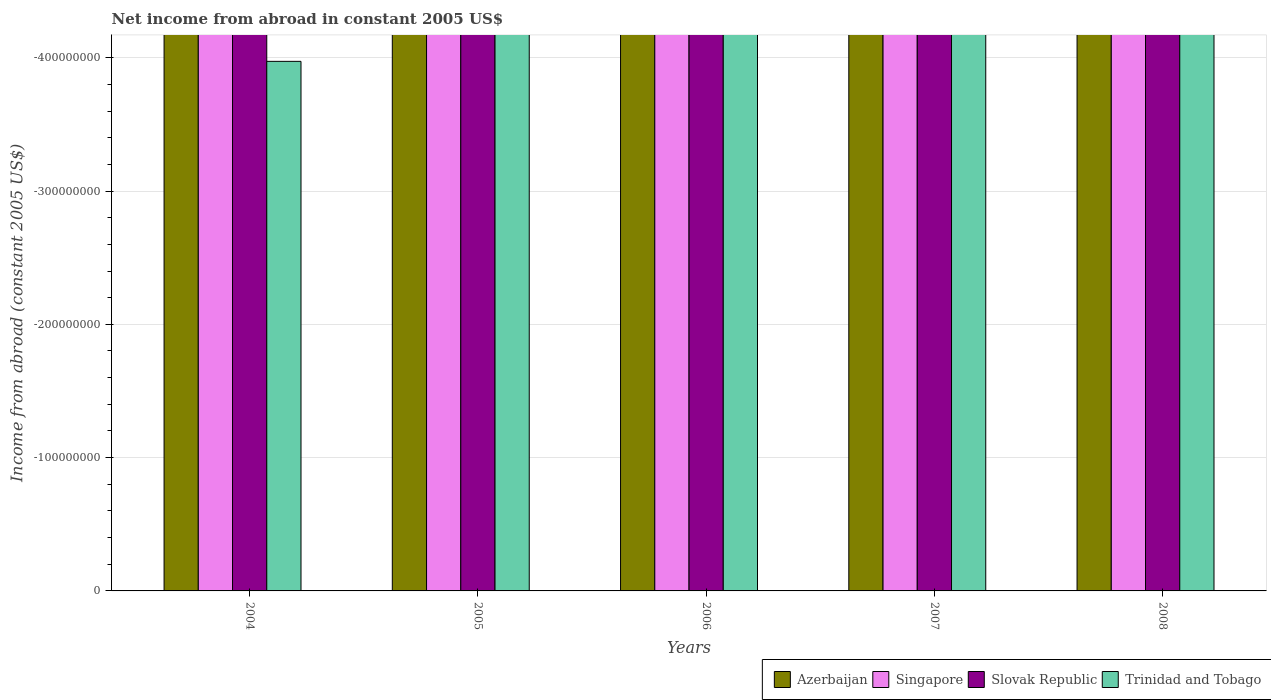Are the number of bars per tick equal to the number of legend labels?
Your response must be concise. No. In how many cases, is the number of bars for a given year not equal to the number of legend labels?
Your answer should be compact. 5. What is the net income from abroad in Slovak Republic in 2006?
Offer a very short reply. 0. What is the difference between the net income from abroad in Azerbaijan in 2007 and the net income from abroad in Trinidad and Tobago in 2005?
Offer a terse response. 0. What is the average net income from abroad in Slovak Republic per year?
Offer a terse response. 0. In how many years, is the net income from abroad in Singapore greater than the average net income from abroad in Singapore taken over all years?
Your answer should be very brief. 0. Is it the case that in every year, the sum of the net income from abroad in Trinidad and Tobago and net income from abroad in Slovak Republic is greater than the net income from abroad in Singapore?
Offer a terse response. No. How many bars are there?
Offer a terse response. 0. Where does the legend appear in the graph?
Your response must be concise. Bottom right. What is the title of the graph?
Offer a very short reply. Net income from abroad in constant 2005 US$. Does "Norway" appear as one of the legend labels in the graph?
Keep it short and to the point. No. What is the label or title of the X-axis?
Offer a very short reply. Years. What is the label or title of the Y-axis?
Give a very brief answer. Income from abroad (constant 2005 US$). What is the Income from abroad (constant 2005 US$) in Singapore in 2004?
Your answer should be compact. 0. What is the Income from abroad (constant 2005 US$) of Trinidad and Tobago in 2004?
Provide a short and direct response. 0. What is the Income from abroad (constant 2005 US$) in Azerbaijan in 2005?
Your response must be concise. 0. What is the Income from abroad (constant 2005 US$) of Singapore in 2005?
Keep it short and to the point. 0. What is the Income from abroad (constant 2005 US$) of Trinidad and Tobago in 2005?
Provide a succinct answer. 0. What is the Income from abroad (constant 2005 US$) of Azerbaijan in 2006?
Provide a short and direct response. 0. What is the Income from abroad (constant 2005 US$) in Slovak Republic in 2006?
Your answer should be compact. 0. What is the Income from abroad (constant 2005 US$) of Azerbaijan in 2007?
Offer a very short reply. 0. What is the Income from abroad (constant 2005 US$) in Slovak Republic in 2007?
Make the answer very short. 0. What is the Income from abroad (constant 2005 US$) in Slovak Republic in 2008?
Your answer should be compact. 0. What is the Income from abroad (constant 2005 US$) in Trinidad and Tobago in 2008?
Offer a terse response. 0. What is the total Income from abroad (constant 2005 US$) in Slovak Republic in the graph?
Your response must be concise. 0. What is the average Income from abroad (constant 2005 US$) of Azerbaijan per year?
Make the answer very short. 0. What is the average Income from abroad (constant 2005 US$) of Singapore per year?
Offer a very short reply. 0. What is the average Income from abroad (constant 2005 US$) of Slovak Republic per year?
Provide a short and direct response. 0. 